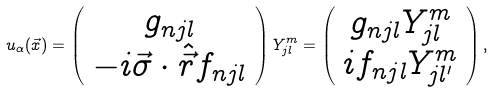Convert formula to latex. <formula><loc_0><loc_0><loc_500><loc_500>u _ { \alpha } ( \vec { x } ) = \left ( \begin{array} { c } g _ { n j l } \\ - i \vec { \sigma } \cdot \hat { \vec { r } } f _ { n j l } \end{array} \right ) Y _ { j l } ^ { m } = \left ( \begin{array} { c } g _ { n j l } Y _ { j l } ^ { m } \\ i f _ { n j l } Y _ { j l ^ { \prime } } ^ { m } \end{array} \right ) ,</formula> 